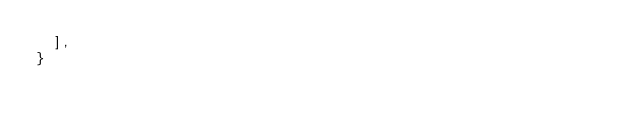Convert code to text. <code><loc_0><loc_0><loc_500><loc_500><_JavaScript_>  ],
}

</code> 